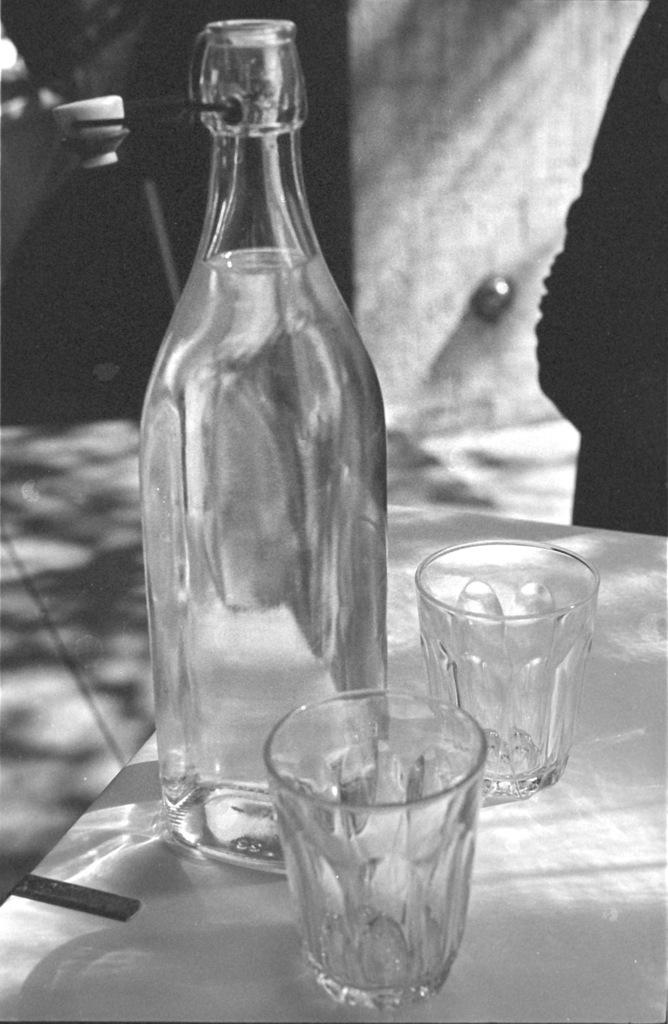What is the main object in the image? There is a glass bottle in the image. How many glasses are present in the image? There are 2 glasses in the image. Where are the glasses located in relation to the glass bottle? The glasses are beside the glass bottle. What type of bait is being used in the image? There is no bait present in the image; it features a glass bottle and glasses. Can you see a chessboard or chess pieces in the image? There is no chessboard or chess pieces present in the image. 